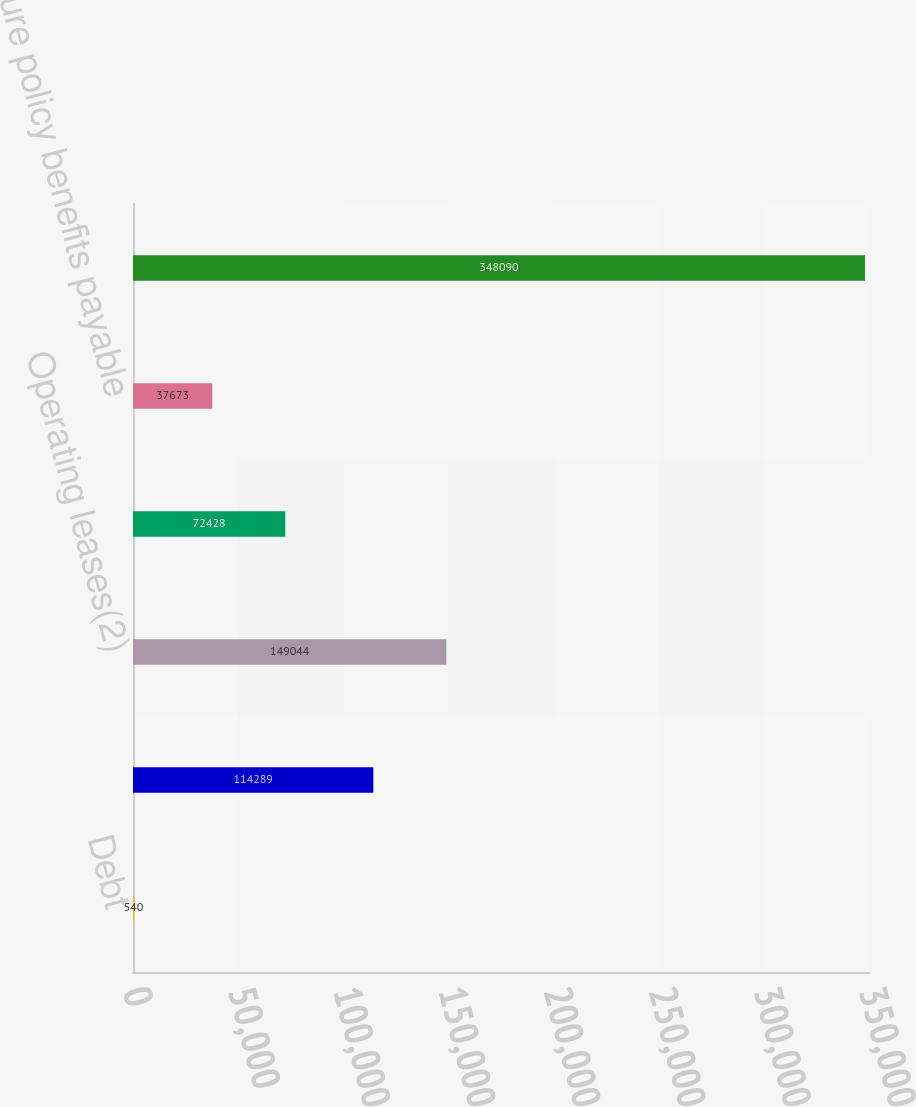Convert chart. <chart><loc_0><loc_0><loc_500><loc_500><bar_chart><fcel>Debt<fcel>Interest(1)<fcel>Operating leases(2)<fcel>Purchase obligations(3)<fcel>Future policy benefits payable<fcel>Total<nl><fcel>540<fcel>114289<fcel>149044<fcel>72428<fcel>37673<fcel>348090<nl></chart> 